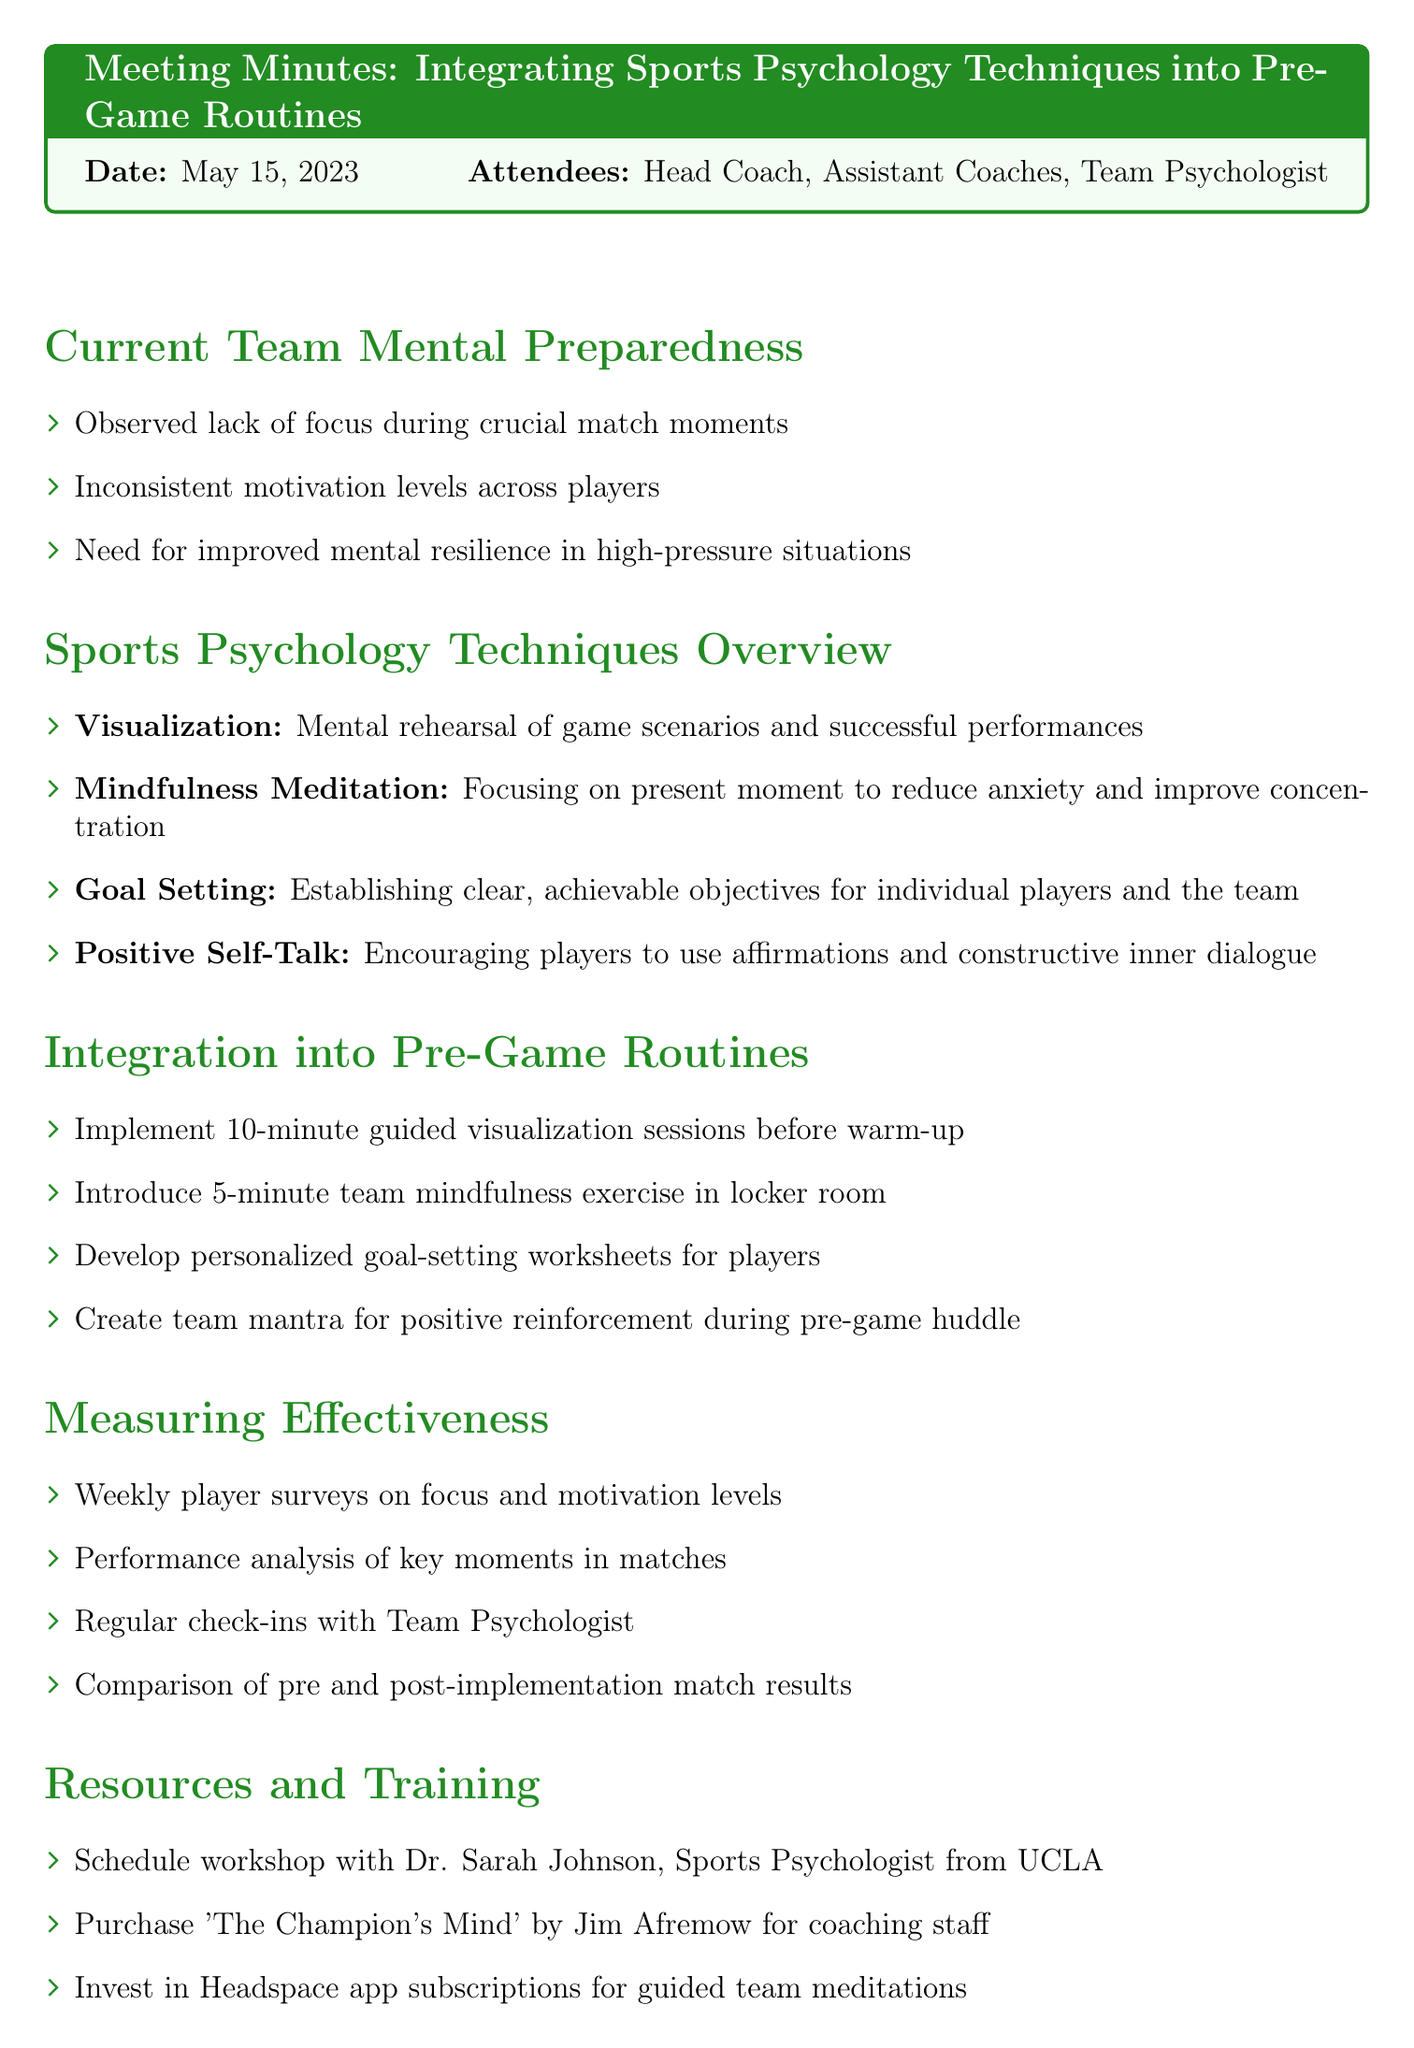What is the date of the meeting? The date of the meeting is mentioned at the beginning of the document.
Answer: May 15, 2023 Who attended the meeting? The attendees list is provided in the document under the attendees section.
Answer: Head Coach, Assistant Coaches, Team Psychologist What is one technique discussed for enhancing mental preparedness? The document lists multiple techniques under the Sports Psychology Techniques Overview section.
Answer: Visualization What is one action item for the integration of sports psychology techniques? The action items for integration are stated in the corresponding section of the document.
Answer: Implement 10-minute guided visualization sessions before warm-up How will the effectiveness of the techniques be measured? The methods for measuring effectiveness are outlined in the Measuring Effectiveness section of the document.
Answer: Weekly player surveys on focus and motivation levels What is a resource mentioned for training? The Resources and Training section lists specific resources that will be utilized.
Answer: Schedule workshop with Dr. Sarah Johnson, Sports Psychologist from UCLA What is the purpose of the follow-up meeting? The next steps include specific actions to take moving forward, including the purpose of the follow-up meeting.
Answer: Review progress in one month What should be communicated to the players? The next steps include specific communications that need to take place.
Answer: New pre-game routine 